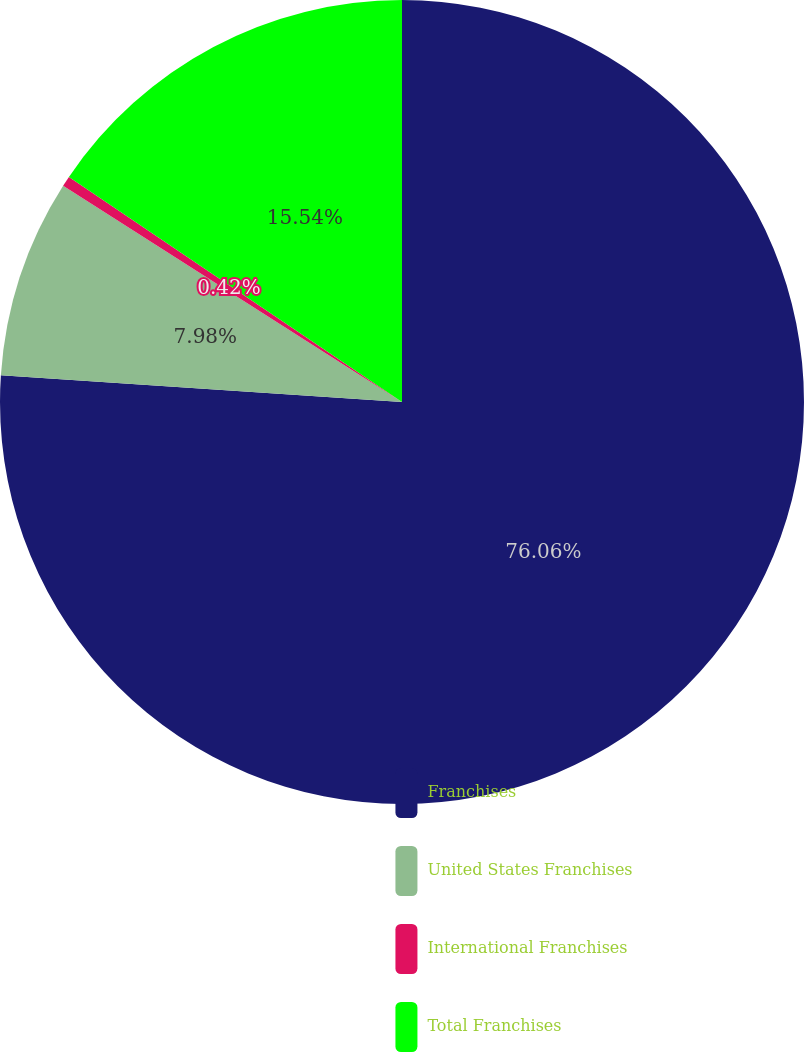<chart> <loc_0><loc_0><loc_500><loc_500><pie_chart><fcel>Franchises<fcel>United States Franchises<fcel>International Franchises<fcel>Total Franchises<nl><fcel>76.06%<fcel>7.98%<fcel>0.42%<fcel>15.54%<nl></chart> 